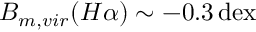Convert formula to latex. <formula><loc_0><loc_0><loc_500><loc_500>B _ { m , v i r } ( H \alpha ) \sim - 0 . 3 \, d e x</formula> 